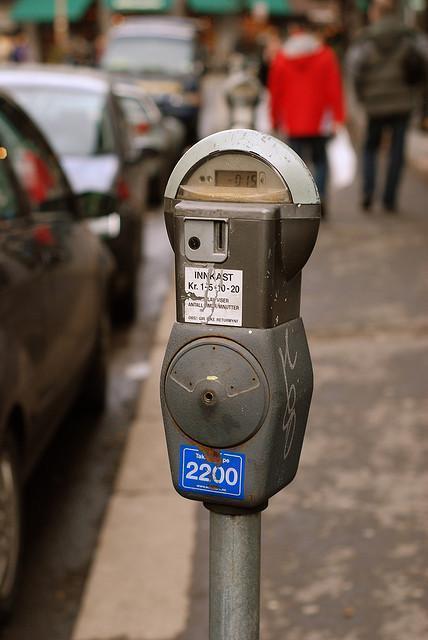What number do you get if you add 10 to the number at the bottom of the meter?
From the following set of four choices, select the accurate answer to respond to the question.
Options: 8610, 2210, 445, 3750. 2210. 